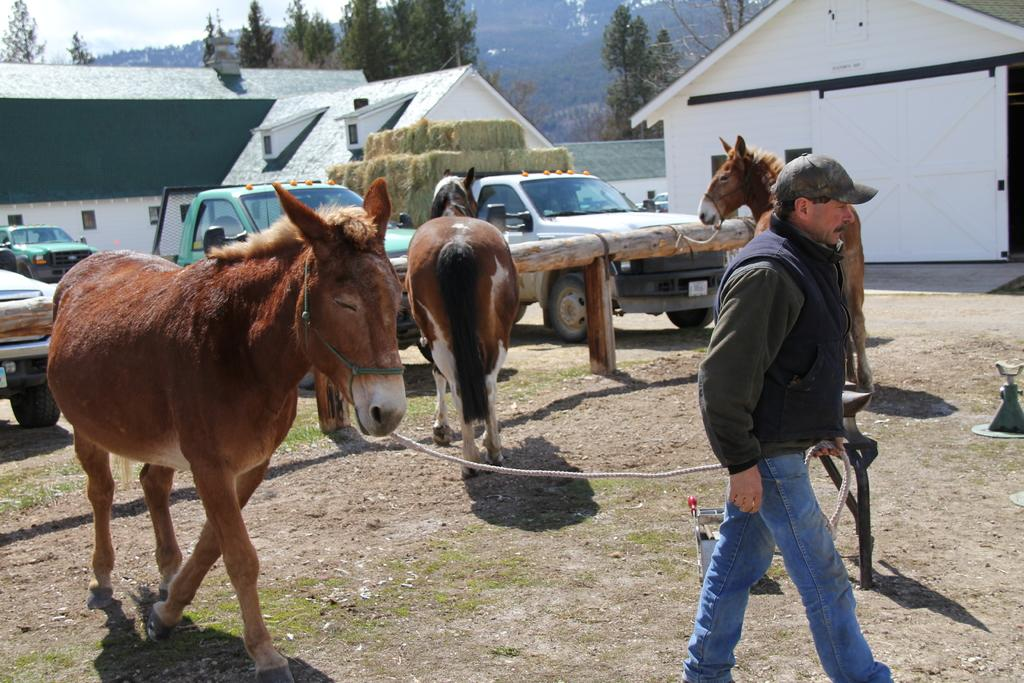What types of transportation can be seen in the image? There are vehicles in the image. What animals are present in the image? There are horses in the image. What is the person holding in the image? The person is holding a rope in the image. What type of structures can be seen in the image? There are buildings in the image. What type of barrier is visible in the image? There is a wooden fence in the image. What type of vegetation is present in the image? There is grass in the image. What type of natural feature is visible in the image? There are trees and mountains in the image. What type of quartz can be seen in the image? There is no quartz present in the image. What type of seed is being planted by the person holding the rope? There is no person planting seeds in the image; the person is holding a rope. What type of bun is being served to the horses in the image? There is no bun present in the image; the animals are horses, not rabbits. 